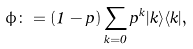Convert formula to latex. <formula><loc_0><loc_0><loc_500><loc_500>\phi \colon = ( 1 - p ) \sum _ { k = 0 } p ^ { k } | k \rangle \langle k | ,</formula> 